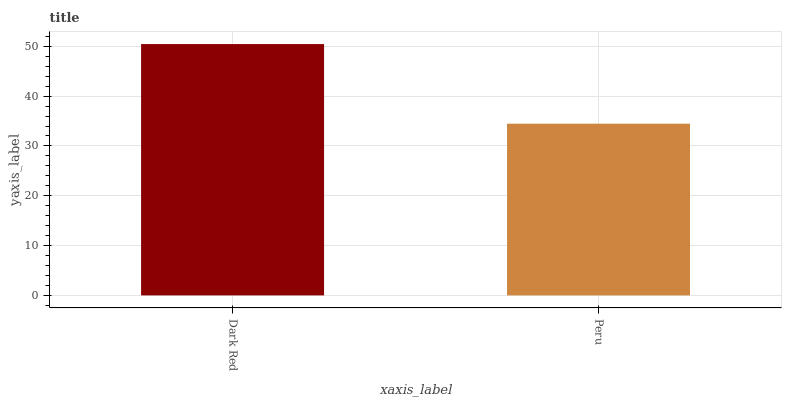Is Peru the minimum?
Answer yes or no. Yes. Is Dark Red the maximum?
Answer yes or no. Yes. Is Peru the maximum?
Answer yes or no. No. Is Dark Red greater than Peru?
Answer yes or no. Yes. Is Peru less than Dark Red?
Answer yes or no. Yes. Is Peru greater than Dark Red?
Answer yes or no. No. Is Dark Red less than Peru?
Answer yes or no. No. Is Dark Red the high median?
Answer yes or no. Yes. Is Peru the low median?
Answer yes or no. Yes. Is Peru the high median?
Answer yes or no. No. Is Dark Red the low median?
Answer yes or no. No. 